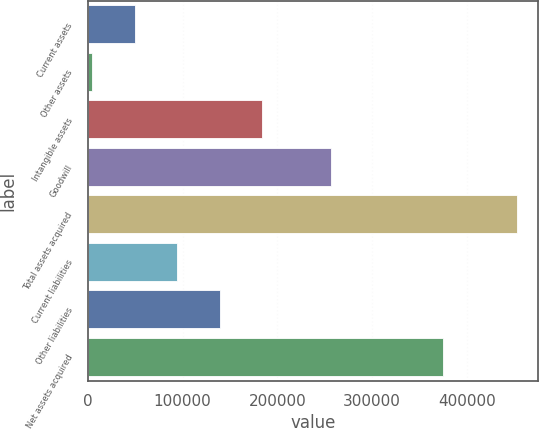Convert chart. <chart><loc_0><loc_0><loc_500><loc_500><bar_chart><fcel>Current assets<fcel>Other assets<fcel>Intangible assets<fcel>Goodwill<fcel>Total assets acquired<fcel>Current liabilities<fcel>Other liabilities<fcel>Net assets acquired<nl><fcel>49686.4<fcel>4916<fcel>183998<fcel>256693<fcel>452620<fcel>94456.8<fcel>139227<fcel>374910<nl></chart> 